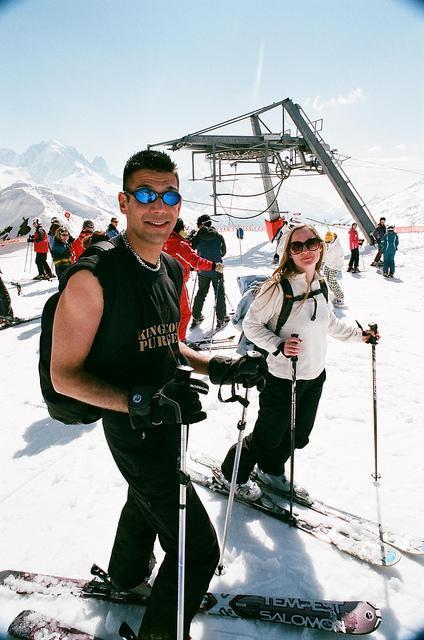How many people are there?
Give a very brief answer. 3. How many ski are in the picture?
Give a very brief answer. 2. 